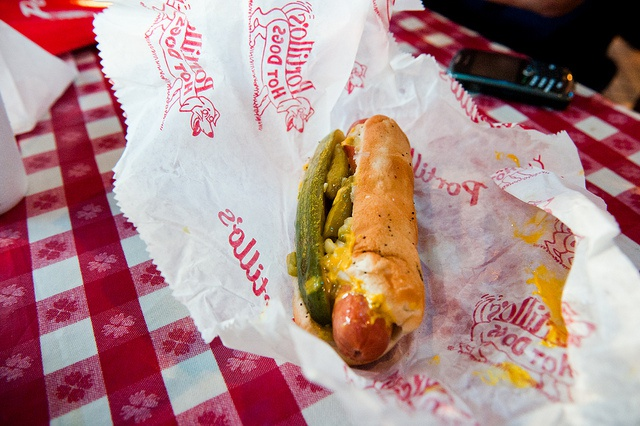Describe the objects in this image and their specific colors. I can see dining table in lightgray, darkgray, maroon, and brown tones, hot dog in maroon, olive, and orange tones, cell phone in maroon, black, teal, and darkblue tones, and bottle in maroon, darkgray, brown, lightgray, and gray tones in this image. 